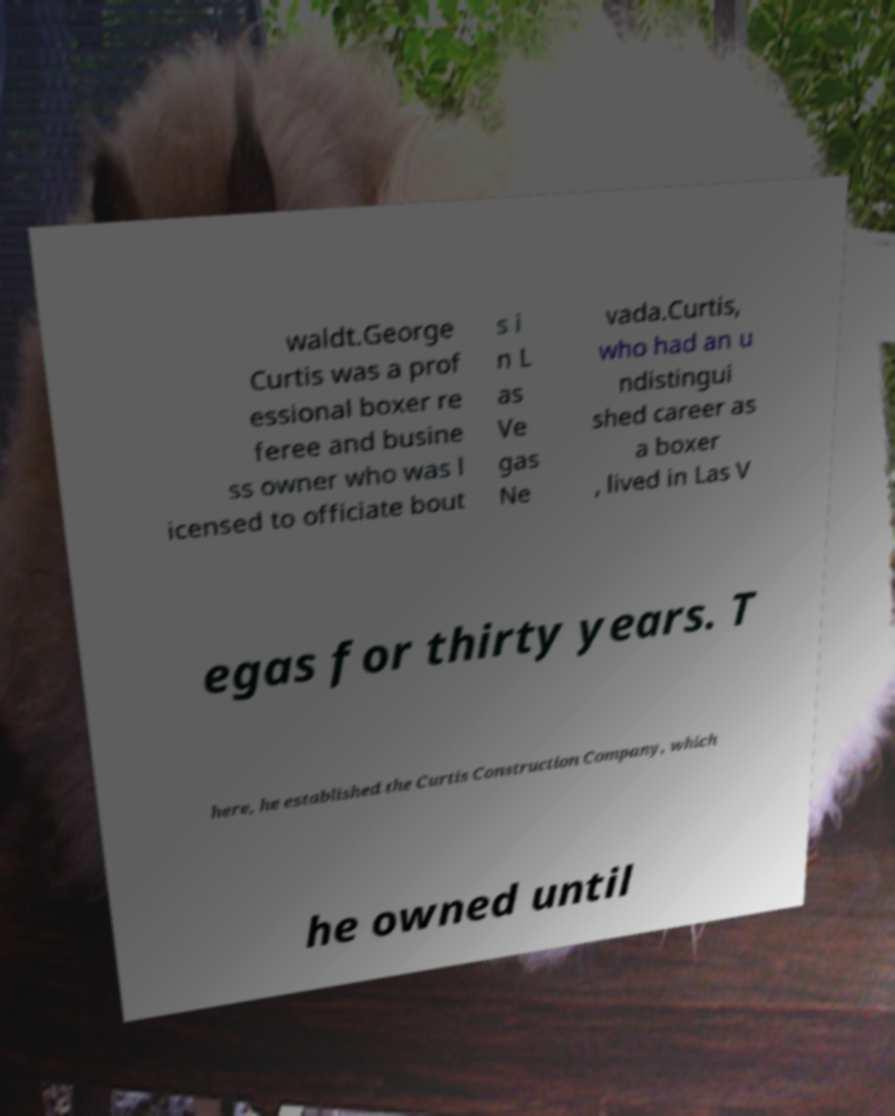I need the written content from this picture converted into text. Can you do that? waldt.George Curtis was a prof essional boxer re feree and busine ss owner who was l icensed to officiate bout s i n L as Ve gas Ne vada.Curtis, who had an u ndistingui shed career as a boxer , lived in Las V egas for thirty years. T here, he established the Curtis Construction Company, which he owned until 